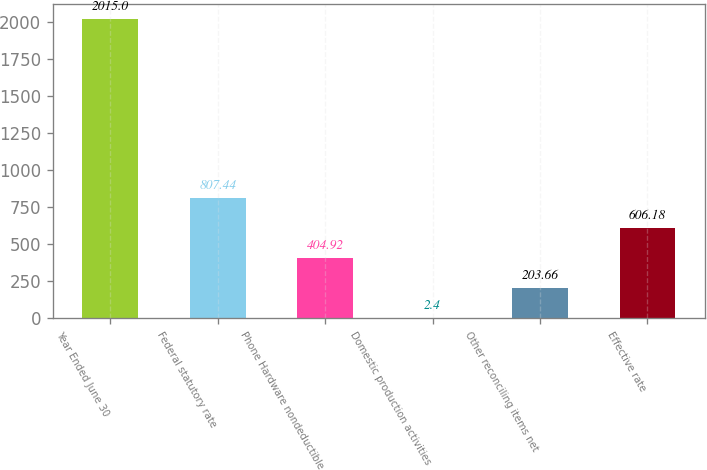Convert chart to OTSL. <chart><loc_0><loc_0><loc_500><loc_500><bar_chart><fcel>Year Ended June 30<fcel>Federal statutory rate<fcel>Phone Hardware nondeductible<fcel>Domestic production activities<fcel>Other reconciling items net<fcel>Effective rate<nl><fcel>2015<fcel>807.44<fcel>404.92<fcel>2.4<fcel>203.66<fcel>606.18<nl></chart> 